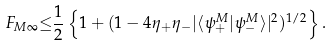<formula> <loc_0><loc_0><loc_500><loc_500>F _ { M \infty } { \leq } \frac { 1 } { 2 } \left \{ 1 + ( 1 - 4 { \eta } _ { + } { \eta } _ { - } | { \langle } { \psi } ^ { M } _ { + } | { \psi } _ { - } ^ { M } { \rangle } | ^ { 2 } ) ^ { 1 / 2 } \right \} .</formula> 